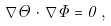<formula> <loc_0><loc_0><loc_500><loc_500>\, \nabla \Theta \cdot \, \nabla \Phi = 0 \, ,</formula> 